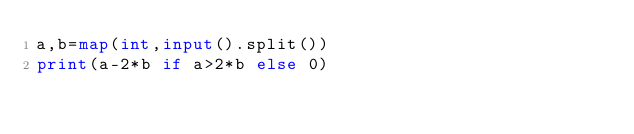Convert code to text. <code><loc_0><loc_0><loc_500><loc_500><_Python_>a,b=map(int,input().split())
print(a-2*b if a>2*b else 0)</code> 